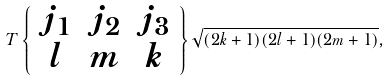Convert formula to latex. <formula><loc_0><loc_0><loc_500><loc_500>T \left \{ \begin{array} { c c c } j _ { 1 } & j _ { 2 } & j _ { 3 } \\ l & m & k \end{array} \right \} \sqrt { ( 2 k + 1 ) ( 2 l + 1 ) ( 2 m + 1 ) } ,</formula> 